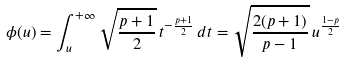<formula> <loc_0><loc_0><loc_500><loc_500>\phi ( u ) = \int _ { u } ^ { + \infty } \sqrt { \frac { p + 1 } { 2 } } \, t ^ { - \frac { p + 1 } { 2 } } \, d t = \sqrt { \frac { 2 ( p + 1 ) } { p - 1 } } \, u ^ { \frac { 1 - p } { 2 } }</formula> 